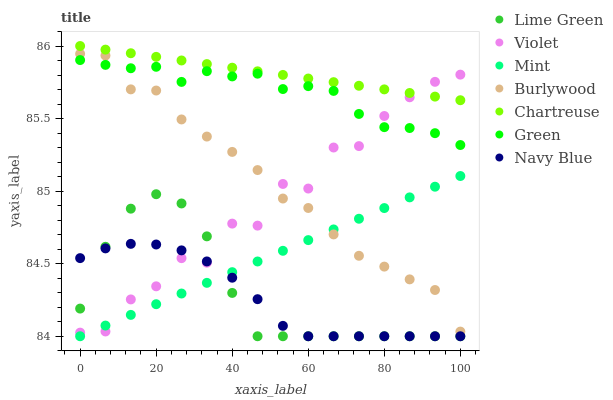Does Navy Blue have the minimum area under the curve?
Answer yes or no. Yes. Does Chartreuse have the maximum area under the curve?
Answer yes or no. Yes. Does Lime Green have the minimum area under the curve?
Answer yes or no. No. Does Lime Green have the maximum area under the curve?
Answer yes or no. No. Is Mint the smoothest?
Answer yes or no. Yes. Is Violet the roughest?
Answer yes or no. Yes. Is Lime Green the smoothest?
Answer yes or no. No. Is Lime Green the roughest?
Answer yes or no. No. Does Lime Green have the lowest value?
Answer yes or no. Yes. Does Chartreuse have the lowest value?
Answer yes or no. No. Does Chartreuse have the highest value?
Answer yes or no. Yes. Does Lime Green have the highest value?
Answer yes or no. No. Is Navy Blue less than Green?
Answer yes or no. Yes. Is Chartreuse greater than Green?
Answer yes or no. Yes. Does Navy Blue intersect Lime Green?
Answer yes or no. Yes. Is Navy Blue less than Lime Green?
Answer yes or no. No. Is Navy Blue greater than Lime Green?
Answer yes or no. No. Does Navy Blue intersect Green?
Answer yes or no. No. 